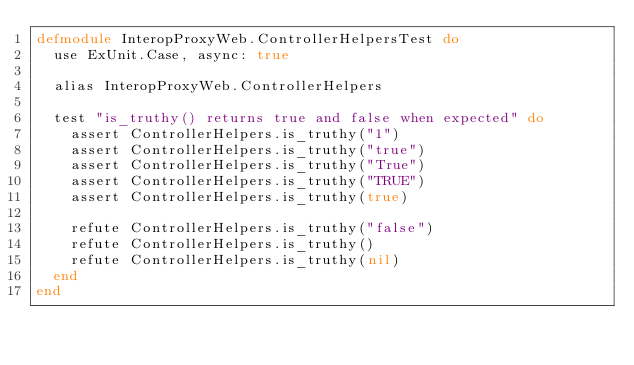<code> <loc_0><loc_0><loc_500><loc_500><_Elixir_>defmodule InteropProxyWeb.ControllerHelpersTest do
  use ExUnit.Case, async: true

  alias InteropProxyWeb.ControllerHelpers

  test "is_truthy() returns true and false when expected" do
    assert ControllerHelpers.is_truthy("1")
    assert ControllerHelpers.is_truthy("true")
    assert ControllerHelpers.is_truthy("True")
    assert ControllerHelpers.is_truthy("TRUE")
    assert ControllerHelpers.is_truthy(true)

    refute ControllerHelpers.is_truthy("false")
    refute ControllerHelpers.is_truthy()
    refute ControllerHelpers.is_truthy(nil)
  end
end
</code> 